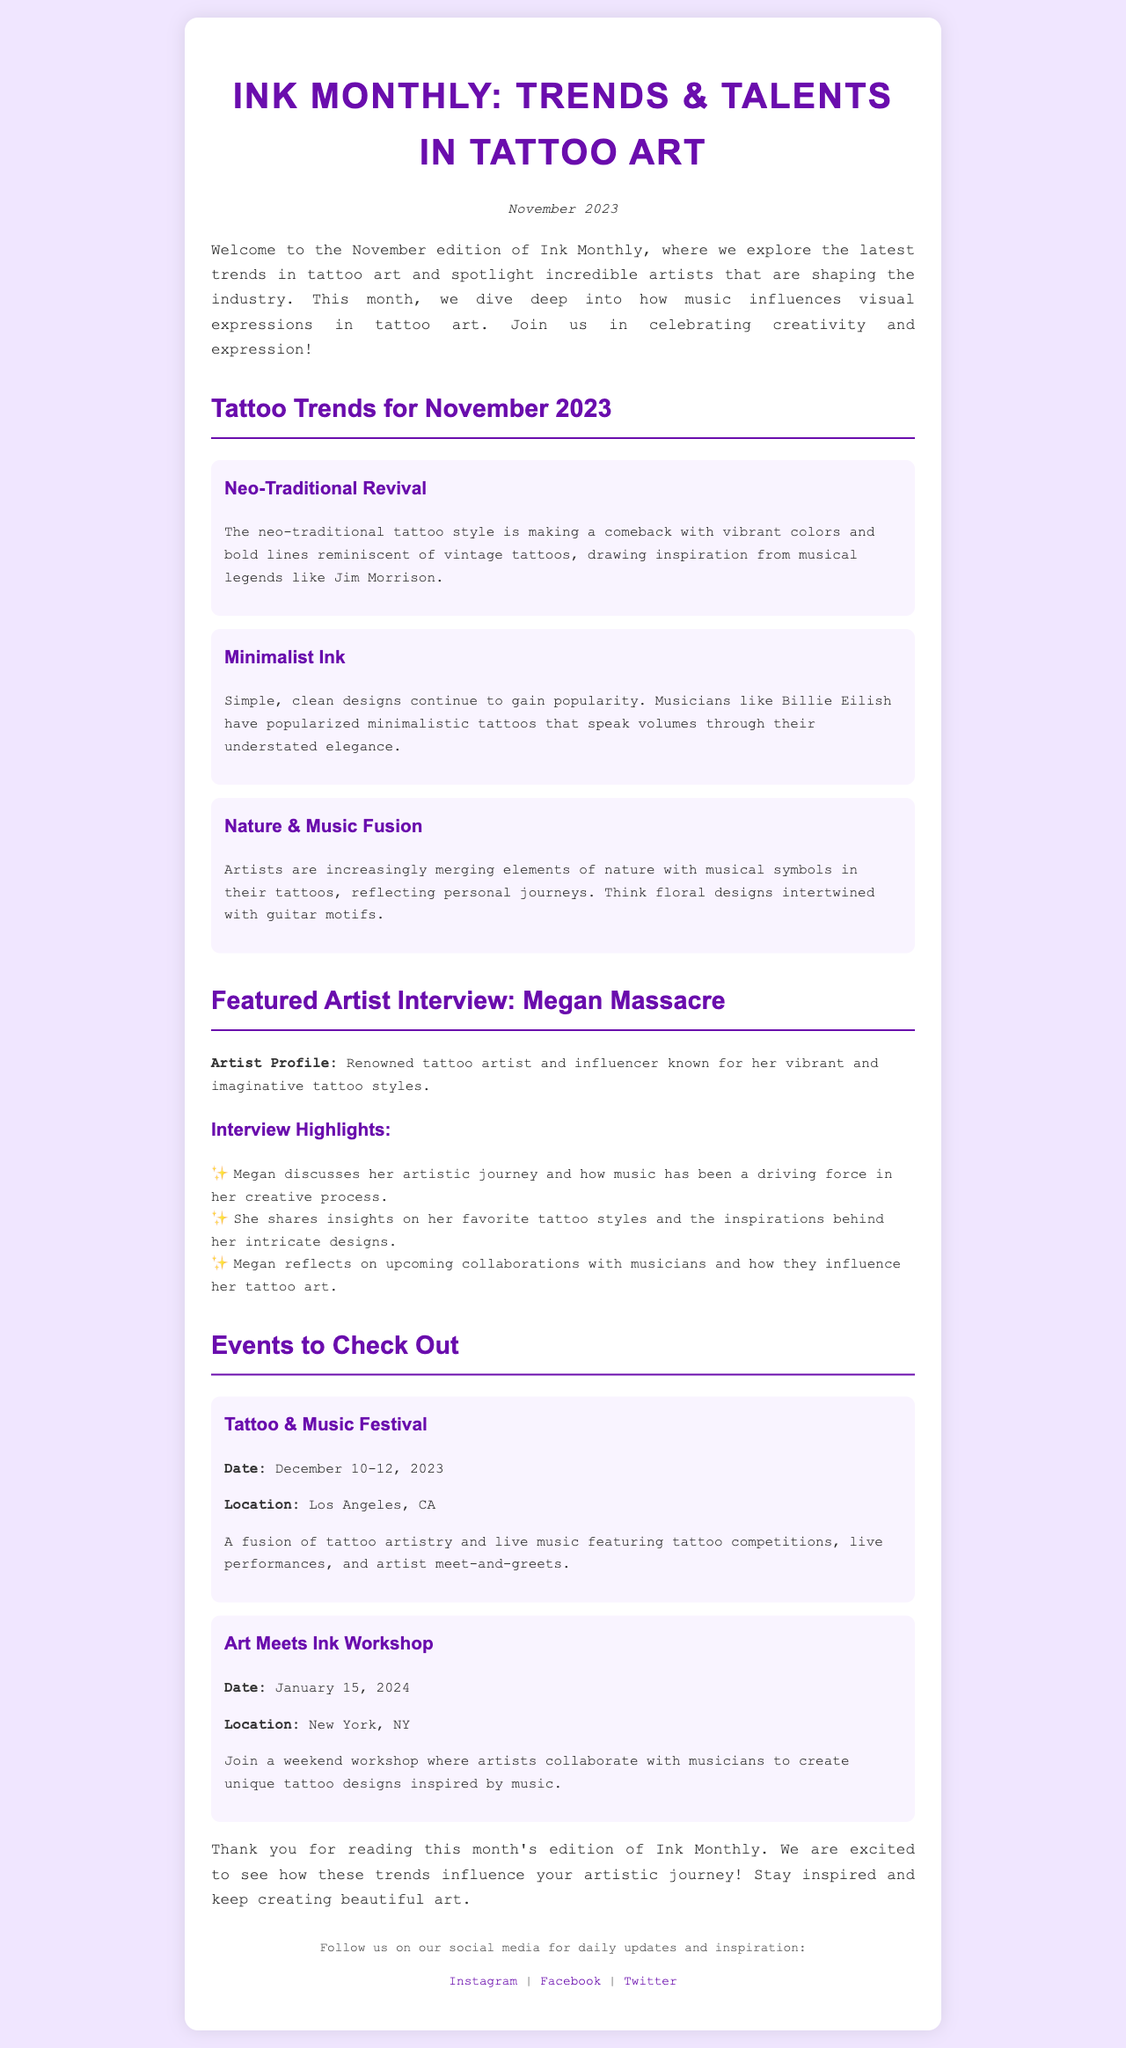What is the title of the newsletter? The title of the newsletter is given in the main heading of the document.
Answer: Ink Monthly: Trends & Talents in Tattoo Art When was this edition published? The publication date is mentioned in the date section of the document.
Answer: November 2023 Who is the featured artist in this edition? The document includes a specific section highlighting the featured artist.
Answer: Megan Massacre What trend involves elements of nature and music? The trend is discussed in the section about tattoo trends for November.
Answer: Nature & Music Fusion When is the Tattoo & Music Festival taking place? The event date is specified under the events section of the newsletter.
Answer: December 10-12, 2023 What style is making a comeback according to the trends? The style is mentioned in the tattoo trends section, indicating its revival.
Answer: Neo-Traditional Revival What type of workshop is mentioned for January 2024? The document describes the focus of the upcoming workshop in January.
Answer: Art Meets Ink Workshop How are musicians influencing tattoo art according to the interview? The influence of music on tattoo art is discussed in the interview highlights section.
Answer: Driving force What color scheme is used for the newsletter's background? The background color is described in the styling of the document.
Answer: #f0e6ff 